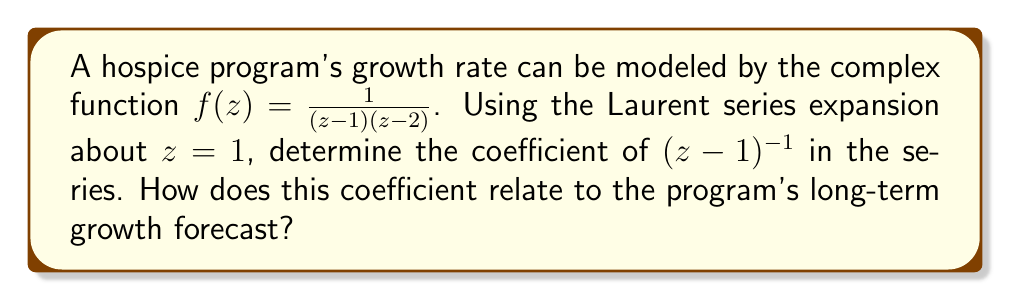Provide a solution to this math problem. To solve this problem, we'll follow these steps:

1) The Laurent series expansion about $z=1$ for $f(z) = \frac{1}{(z-1)(z-2)}$ can be found using partial fraction decomposition:

   $$f(z) = \frac{1}{(z-1)(z-2)} = \frac{A}{z-1} + \frac{B}{z-2}$$

2) To find A and B:
   $$1 = A(z-2) + B(z-1)$$
   When $z = 1$: $1 = A(-1) + B(0)$, so $A = -1$
   When $z = 2$: $1 = A(0) + B(1)$, so $B = 1$

3) Therefore:
   $$f(z) = \frac{-1}{z-1} + \frac{1}{z-2}$$

4) Now, we focus on the term $\frac{-1}{z-1}$. This can be expanded as a geometric series:

   $$\frac{-1}{z-1} = -\frac{1}{1-(1-z)} = -(1 + (1-z) + (1-z)^2 + ...)$$

5) Rearranging this series:

   $$\frac{-1}{z-1} = -1 - (z-1)^{-1} - (z-1)^{-2} - ...$$

6) The coefficient of $(z-1)^{-1}$ in this expansion is $-1$.

7) For the term $\frac{1}{z-2}$, we can expand it about $z=1$:

   $$\frac{1}{z-2} = \frac{1}{(z-1)-1} = -1 + (z-1) - (z-1)^2 + ...$$

8) This expansion doesn't contribute to the $(z-1)^{-1}$ term.

9) Therefore, the coefficient of $(z-1)^{-1}$ in the full Laurent series expansion of $f(z)$ about $z=1$ is $-1$.

In the context of forecasting hospice program growth, the coefficient of $(z-1)^{-1}$ in the Laurent series expansion is often associated with the residue of the function at that point. The residue can be interpreted as a measure of the local behavior of the function near the point of expansion. In this case, a negative coefficient ($-1$) might indicate a declining trend in the immediate vicinity of $z=1$, which could suggest a potential short-term decrease in growth rate. However, for long-term forecasting, one would need to consider the entire Laurent series and possibly other analytical properties of the function.
Answer: The coefficient of $(z-1)^{-1}$ in the Laurent series expansion of $f(z) = \frac{1}{(z-1)(z-2)}$ about $z=1$ is $-1$. 